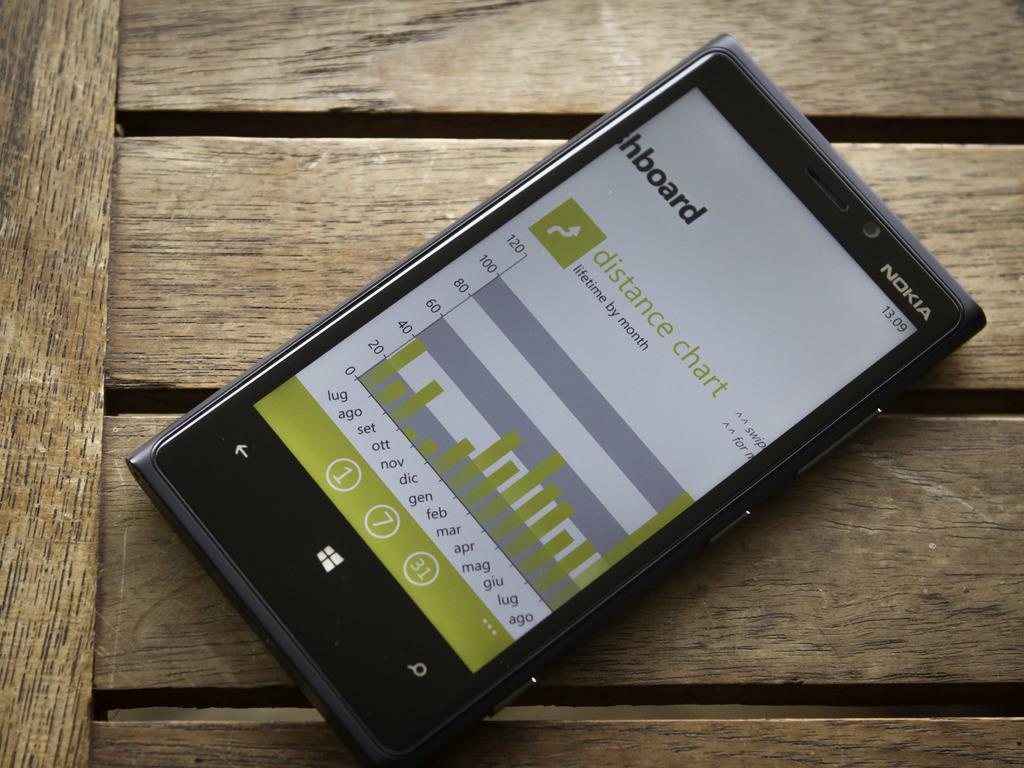<image>
Offer a succinct explanation of the picture presented. A black Nokia phone has a distance chart pulled up on its display. 